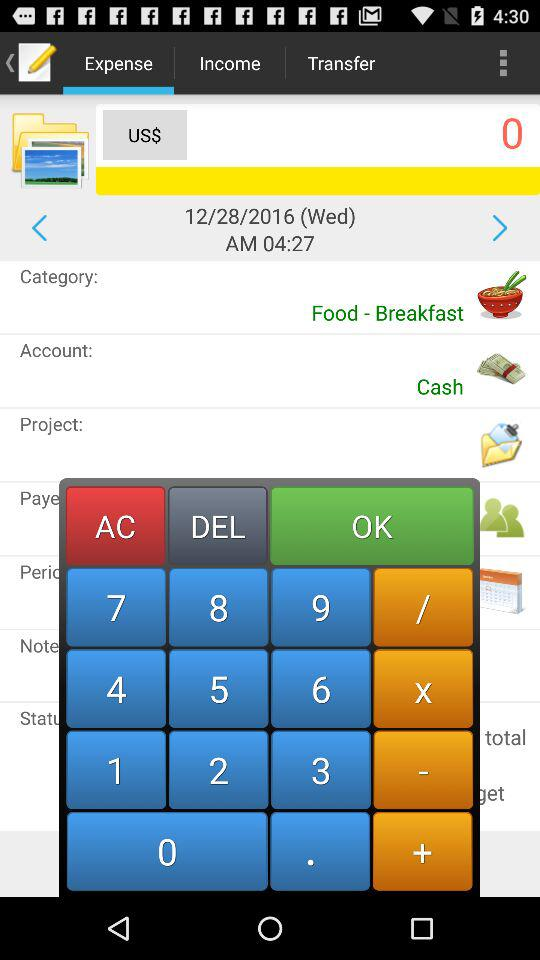What type of account is there? The account type is "Cash". 